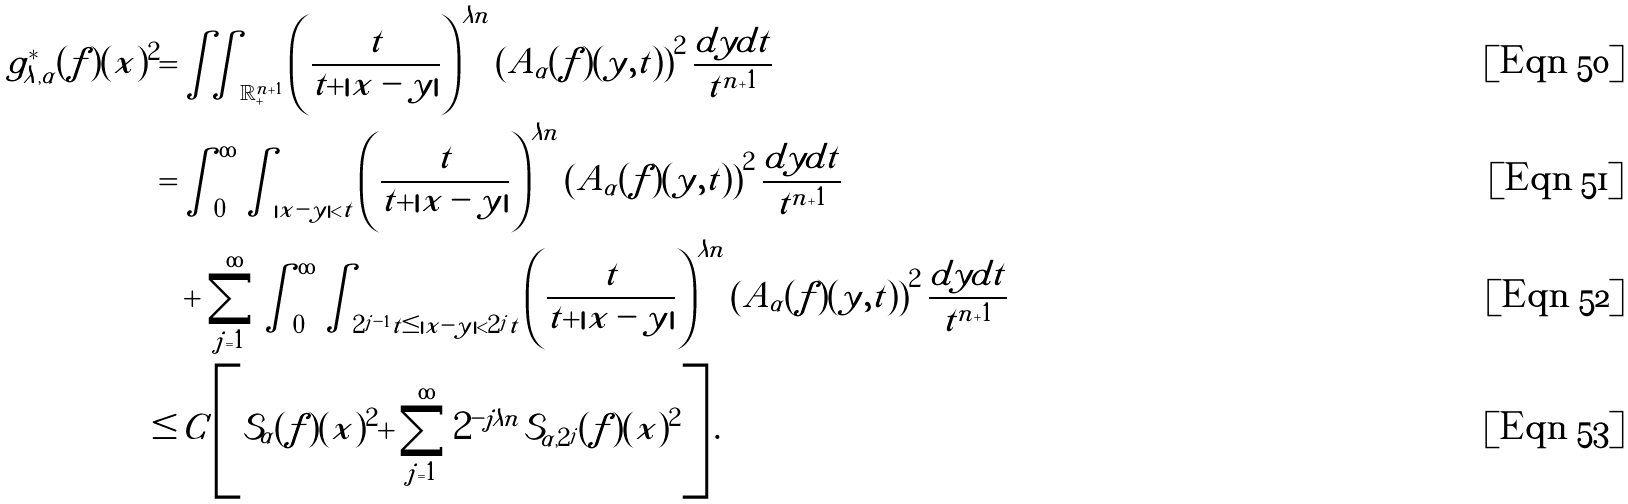Convert formula to latex. <formula><loc_0><loc_0><loc_500><loc_500>g ^ { * } _ { \lambda , \alpha } ( f ) ( x ) ^ { 2 } = & \iint _ { \mathbb { R } ^ { n + 1 } _ { + } } \left ( \frac { t } { t + | x - y | } \right ) ^ { \lambda n } \left ( A _ { \alpha } ( f ) ( y , t ) \right ) ^ { 2 } \frac { d y d t } { t ^ { n + 1 } } \\ = & \int _ { 0 } ^ { \infty } \int _ { | x - y | < t } \left ( \frac { t } { t + | x - y | } \right ) ^ { \lambda n } \left ( A _ { \alpha } ( f ) ( y , t ) \right ) ^ { 2 } \frac { d y d t } { t ^ { n + 1 } } \\ & + \sum _ { j = 1 } ^ { \infty } \int _ { 0 } ^ { \infty } \int _ { 2 ^ { j - 1 } t \leq | x - y | < 2 ^ { j } t } \left ( \frac { t } { t + | x - y | } \right ) ^ { \lambda n } \left ( A _ { \alpha } ( f ) ( y , t ) \right ) ^ { 2 } \frac { d y d t } { t ^ { n + 1 } } \\ \leq & \, C \left [ \mathcal { S } _ { \alpha } ( f ) ( x ) ^ { 2 } + \sum _ { j = 1 } ^ { \infty } 2 ^ { - j \lambda n } \mathcal { S } _ { \alpha , 2 ^ { j } } ( f ) ( x ) ^ { 2 } \right ] .</formula> 